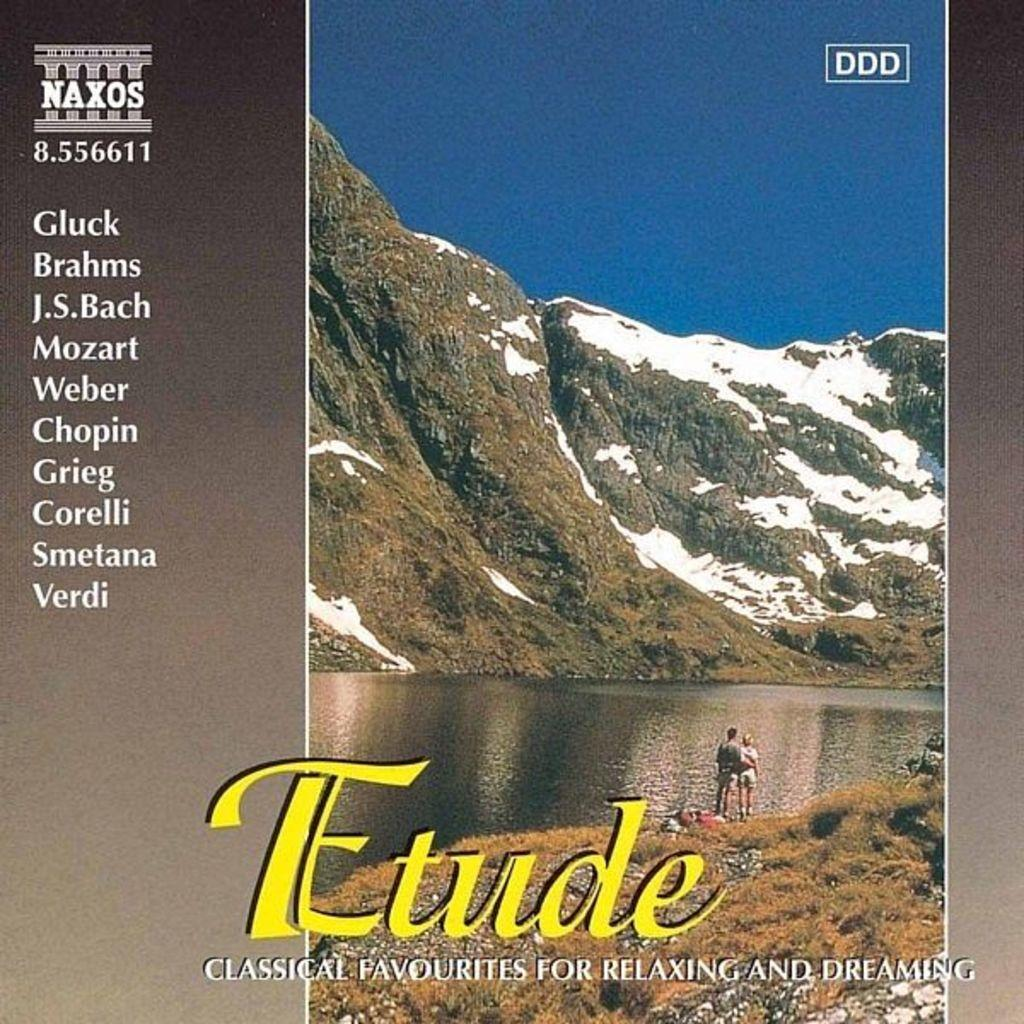<image>
Provide a brief description of the given image. Music album cover showing two people looking at a mountain titled "Etude". 